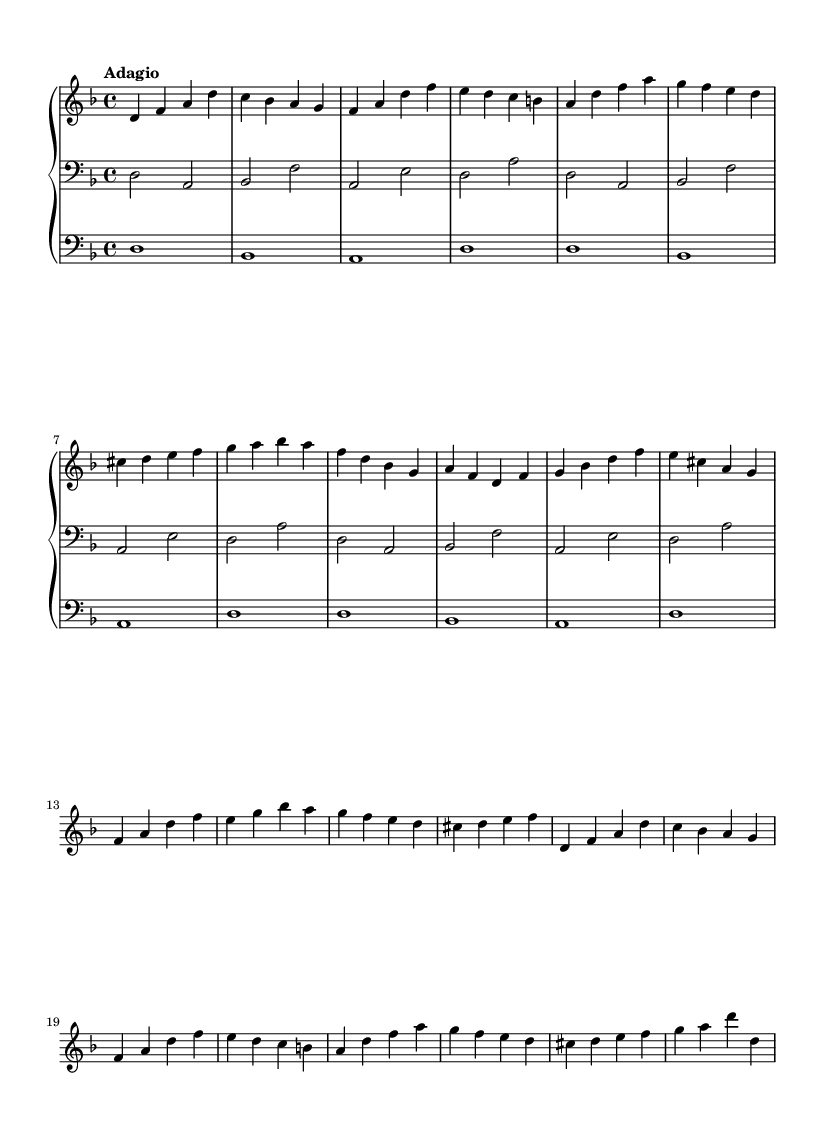What is the key signature of this music? The key signature is indicated by the presence of two flats, which corresponds to the key of D minor.
Answer: D minor What is the time signature of this piece? The time signature is found at the beginning of the piece, shown as a "4/4", indicating four beats per measure.
Answer: 4/4 What is the tempo marking for this composition? The tempo marking is prominently displayed as "Adagio," which suggests a slow tempo.
Answer: Adagio How many lines are there in the right-hand staff? The right-hand staff has five lines, which is standard for conventional musical notation.
Answer: Five What is the range of the pedal part? The pedal part starts on the note D1 and continues to the note D through various repetitions, indicating a limited range based around D.
Answer: D What type of music does this piece represent? This composition is characterized as a "Meditative Baroque organ work," which is indicated by its style, structure, and use of the organ.
Answer: Baroque What is the last note in the right-hand part? The right-hand part ends with a D, which is the concluding note of the last measure shown.
Answer: D 